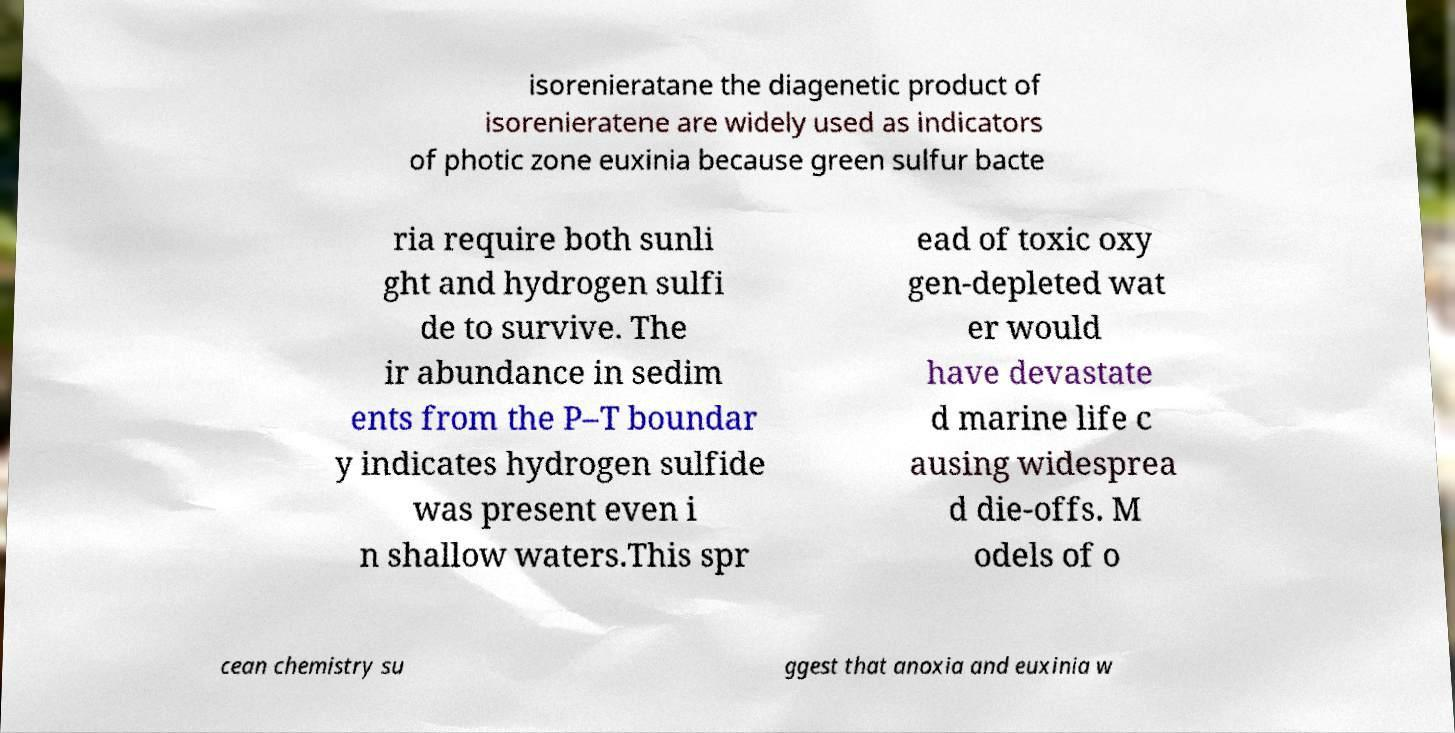What messages or text are displayed in this image? I need them in a readable, typed format. isorenieratane the diagenetic product of isorenieratene are widely used as indicators of photic zone euxinia because green sulfur bacte ria require both sunli ght and hydrogen sulfi de to survive. The ir abundance in sedim ents from the P–T boundar y indicates hydrogen sulfide was present even i n shallow waters.This spr ead of toxic oxy gen-depleted wat er would have devastate d marine life c ausing widesprea d die-offs. M odels of o cean chemistry su ggest that anoxia and euxinia w 